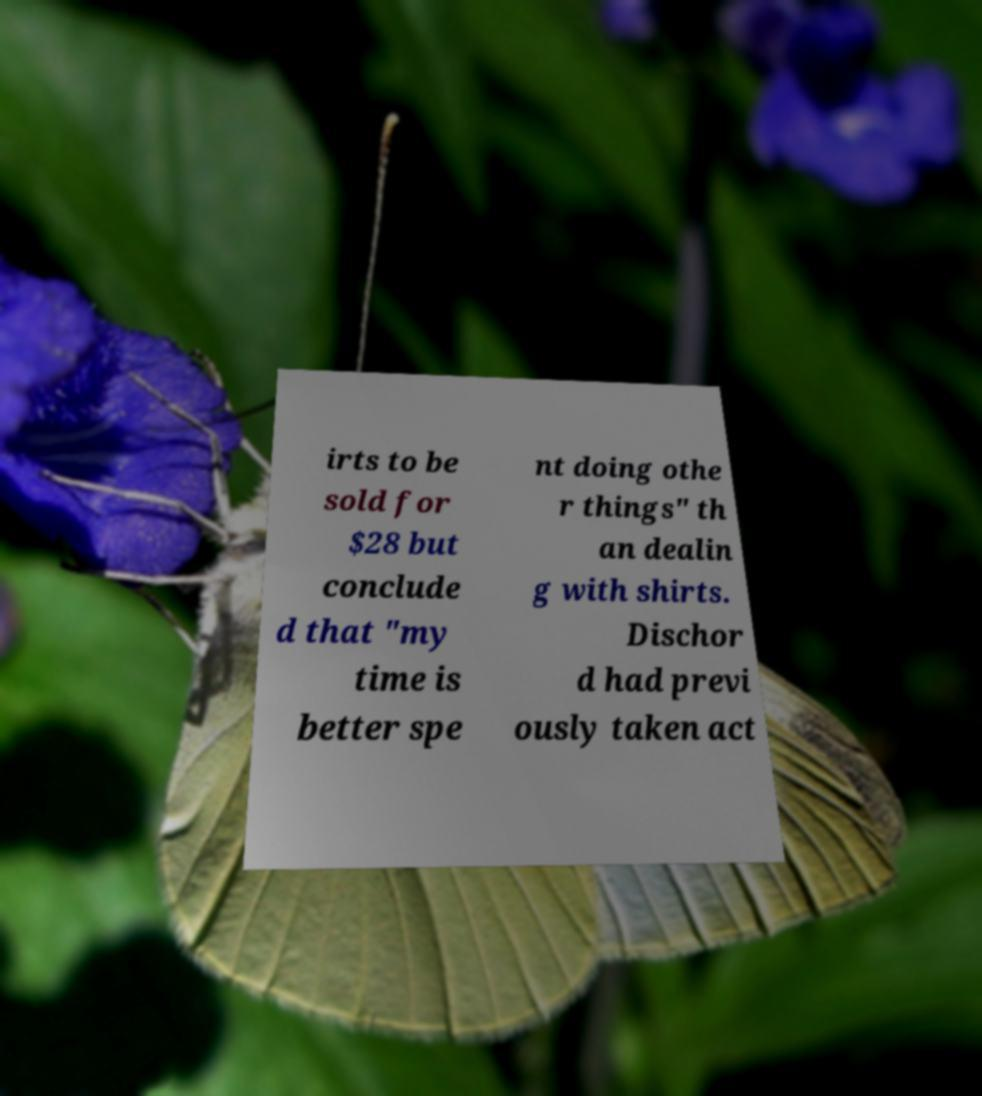Can you read and provide the text displayed in the image?This photo seems to have some interesting text. Can you extract and type it out for me? irts to be sold for $28 but conclude d that "my time is better spe nt doing othe r things" th an dealin g with shirts. Dischor d had previ ously taken act 